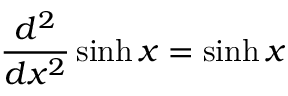Convert formula to latex. <formula><loc_0><loc_0><loc_500><loc_500>{ \frac { d ^ { 2 } } { d x ^ { 2 } } } \sinh x = \sinh x</formula> 